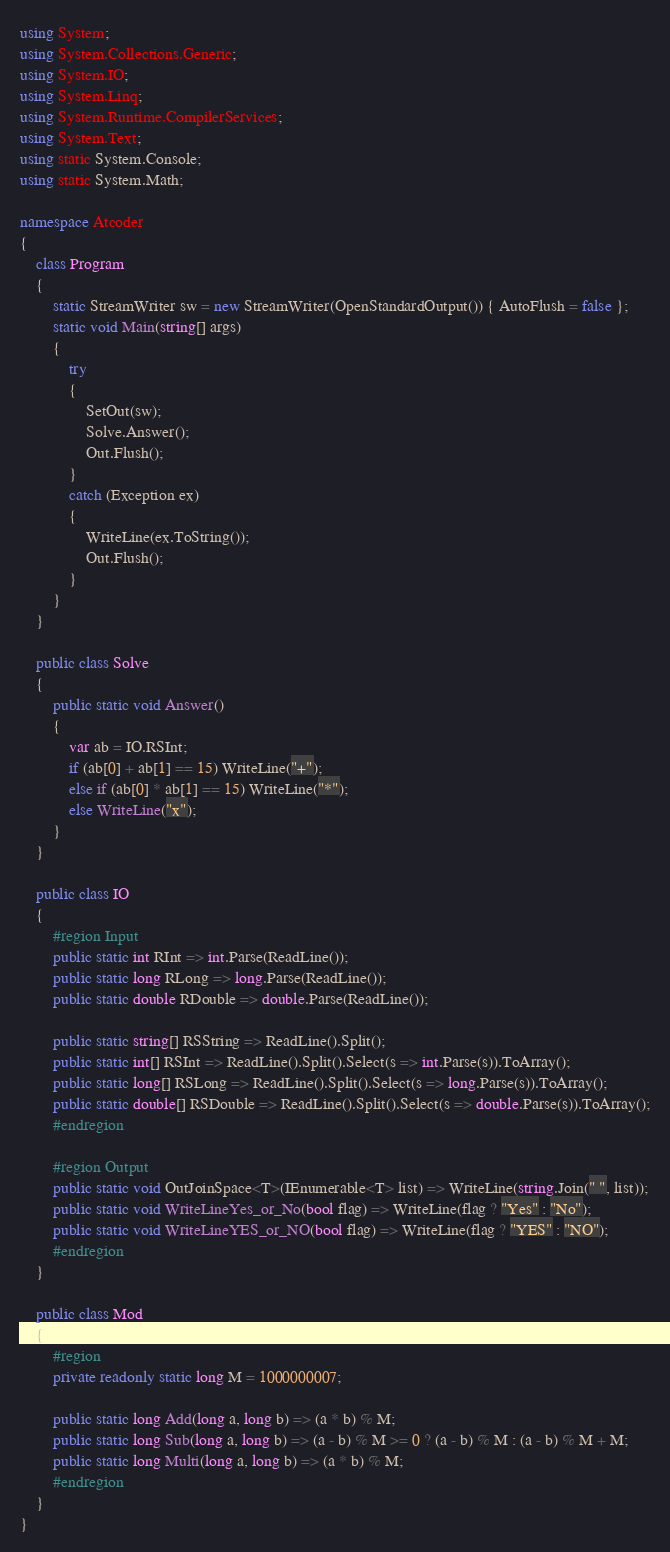<code> <loc_0><loc_0><loc_500><loc_500><_C#_>using System;
using System.Collections.Generic;
using System.IO;
using System.Linq;
using System.Runtime.CompilerServices;
using System.Text;
using static System.Console;
using static System.Math;

namespace Atcoder
{
    class Program
    {
        static StreamWriter sw = new StreamWriter(OpenStandardOutput()) { AutoFlush = false };
        static void Main(string[] args)
        {
            try
            {
                SetOut(sw);
                Solve.Answer();
                Out.Flush();
            }
            catch (Exception ex)
            {
                WriteLine(ex.ToString());
                Out.Flush();
            }
        }
    }

    public class Solve
    {
        public static void Answer()
        {
            var ab = IO.RSInt;
            if (ab[0] + ab[1] == 15) WriteLine("+");
            else if (ab[0] * ab[1] == 15) WriteLine("*");
            else WriteLine("x");
        }
    }

    public class IO
    {
        #region Input
        public static int RInt => int.Parse(ReadLine());
        public static long RLong => long.Parse(ReadLine());
        public static double RDouble => double.Parse(ReadLine());

        public static string[] RSString => ReadLine().Split();
        public static int[] RSInt => ReadLine().Split().Select(s => int.Parse(s)).ToArray();
        public static long[] RSLong => ReadLine().Split().Select(s => long.Parse(s)).ToArray();
        public static double[] RSDouble => ReadLine().Split().Select(s => double.Parse(s)).ToArray();
        #endregion

        #region Output
        public static void OutJoinSpace<T>(IEnumerable<T> list) => WriteLine(string.Join(" ", list));
        public static void WriteLineYes_or_No(bool flag) => WriteLine(flag ? "Yes" : "No");
        public static void WriteLineYES_or_NO(bool flag) => WriteLine(flag ? "YES" : "NO");
        #endregion
    }

    public class Mod
    {
        #region
        private readonly static long M = 1000000007;

        public static long Add(long a, long b) => (a * b) % M;
        public static long Sub(long a, long b) => (a - b) % M >= 0 ? (a - b) % M : (a - b) % M + M;
        public static long Multi(long a, long b) => (a * b) % M;
        #endregion
    }
}</code> 